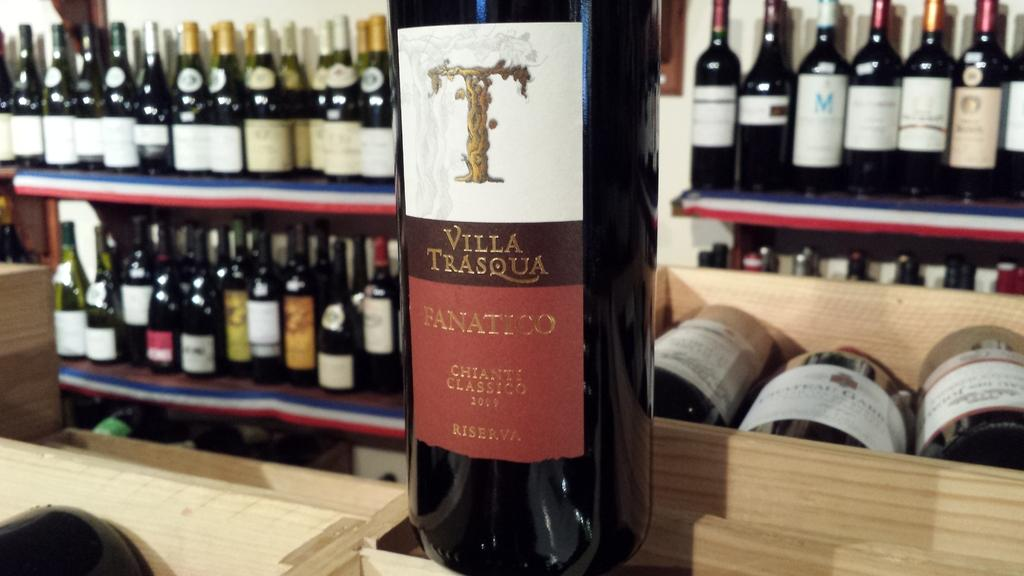<image>
Give a short and clear explanation of the subsequent image. A wine label has a T over Villa Trasqua and Fanatico. 